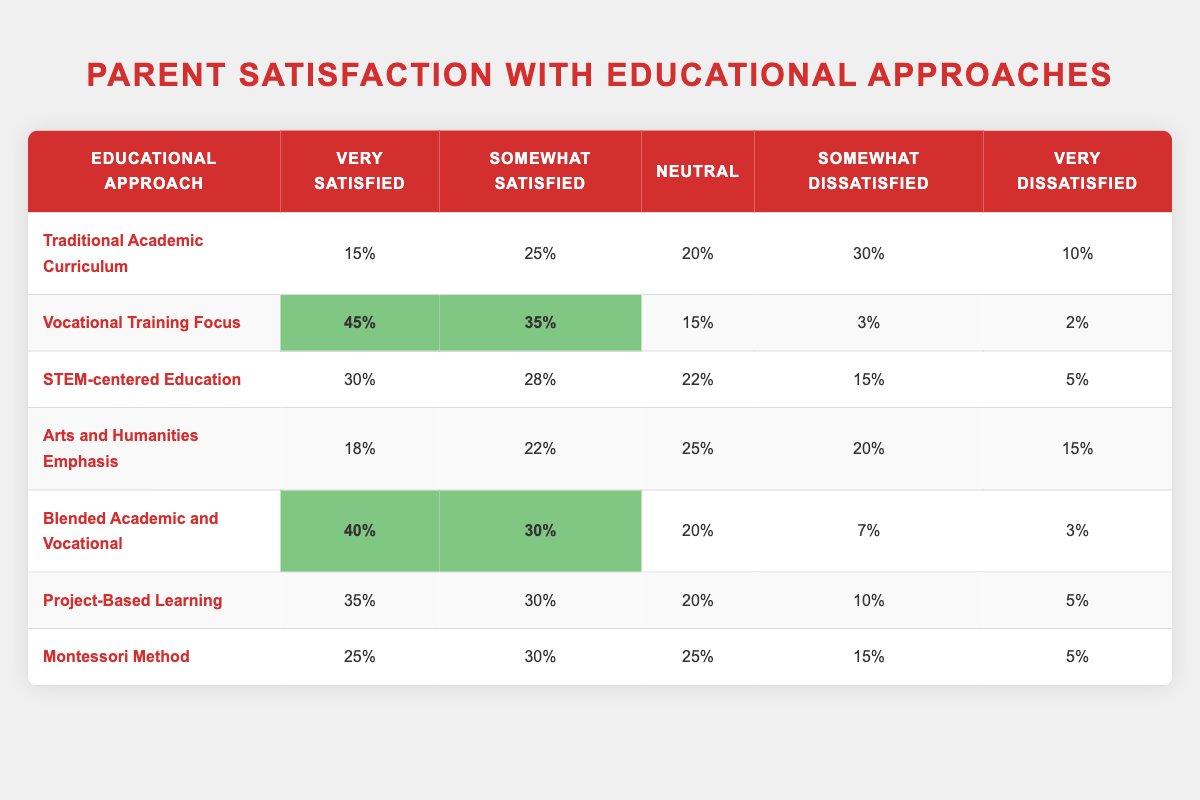What percentage of parents are very satisfied with the Vocational Training Focus? The table shows that 45% of parents are very satisfied with the Vocational Training Focus.
Answer: 45% Which educational approach has the highest percentage of parents who are somewhat satisfied? By comparing the columns under "Somewhat Satisfied," the Vocational Training Focus has the highest percentage at 35%.
Answer: Vocational Training Focus What is the combined percentage of parents who are satisfied (very satisfied and somewhat satisfied) with Project-Based Learning? To find this, add the percentages of "Very Satisfied" (35%) and "Somewhat Satisfied" (30%) for Project-Based Learning. The sum is 35% + 30% = 65%.
Answer: 65% Is it true that more parents are very satisfied with the STEM-centered Education than with the Montessori Method? By examining the percentages in the "Very Satisfied" column, 30% for STEM-centered Education and 25% for Montessori Method, it's clear that more parents are satisfied with STEM-centered Education.
Answer: Yes Which approach has the least percentage of very dissatisfied parents? The percentages for "Very Dissatisfied" are compared: Vocational Training Focus (2%), Blended Academic and Vocational (3%), Traditional Academic Curriculum (10%), Project-Based Learning (5%), Arts and Humanities Emphasis (15%), Montessori Method (5%), STEM-centered Education (5%). Vocational Training Focus has the least at 2%.
Answer: Vocational Training Focus What is the difference between the percentage of parents very satisfied with Traditional Academic Curriculum and those very satisfied with Arts and Humanities Emphasis? Calculate the difference by subtracting the percentage for Arts and Humanities Emphasis (18%) from Traditional Academic Curriculum (15%): 15% - 18% = -3%. This indicates that Arts and Humanities Emphasis has a higher percentage of very satisfied parents.
Answer: -3% Which educational approach has a combined percentage of parents who are dissatisfied (somewhat and very dissatisfied) below 10%? Adding the "Somewhat Dissatisfied" (3%) and "Very Dissatisfied" (2%) percentages for Vocational Training Focus gives 3% + 2% = 5%. This is below 10%.
Answer: Vocational Training Focus Is the percentage of neutral responses higher for Blended Academic and Vocational than for Montessori Method? The neutral responses are compared: Blended Academic and Vocational has 20%, while Montessori Method has 25%. Thus, Montessori Method has a higher percentage of neutral responses.
Answer: No 